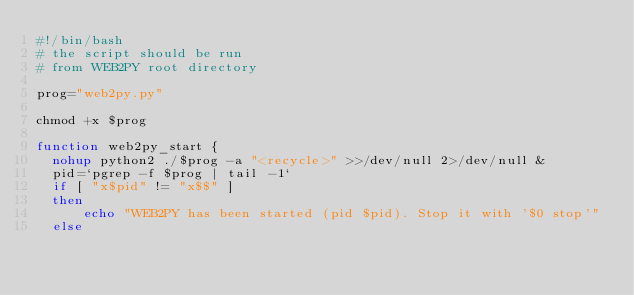<code> <loc_0><loc_0><loc_500><loc_500><_Bash_>#!/bin/bash
# the script should be run
# from WEB2PY root directory

prog="web2py.py"

chmod +x $prog

function web2py_start {
  nohup python2 ./$prog -a "<recycle>" >>/dev/null 2>/dev/null &
  pid=`pgrep -f $prog | tail -1`
  if [ "x$pid" != "x$$" ]
  then
      echo "WEB2PY has been started (pid $pid). Stop it with '$0 stop'"
  else</code> 